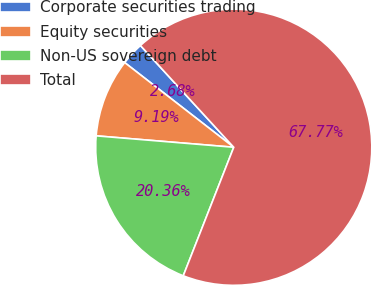Convert chart. <chart><loc_0><loc_0><loc_500><loc_500><pie_chart><fcel>Corporate securities trading<fcel>Equity securities<fcel>Non-US sovereign debt<fcel>Total<nl><fcel>2.68%<fcel>9.19%<fcel>20.36%<fcel>67.77%<nl></chart> 